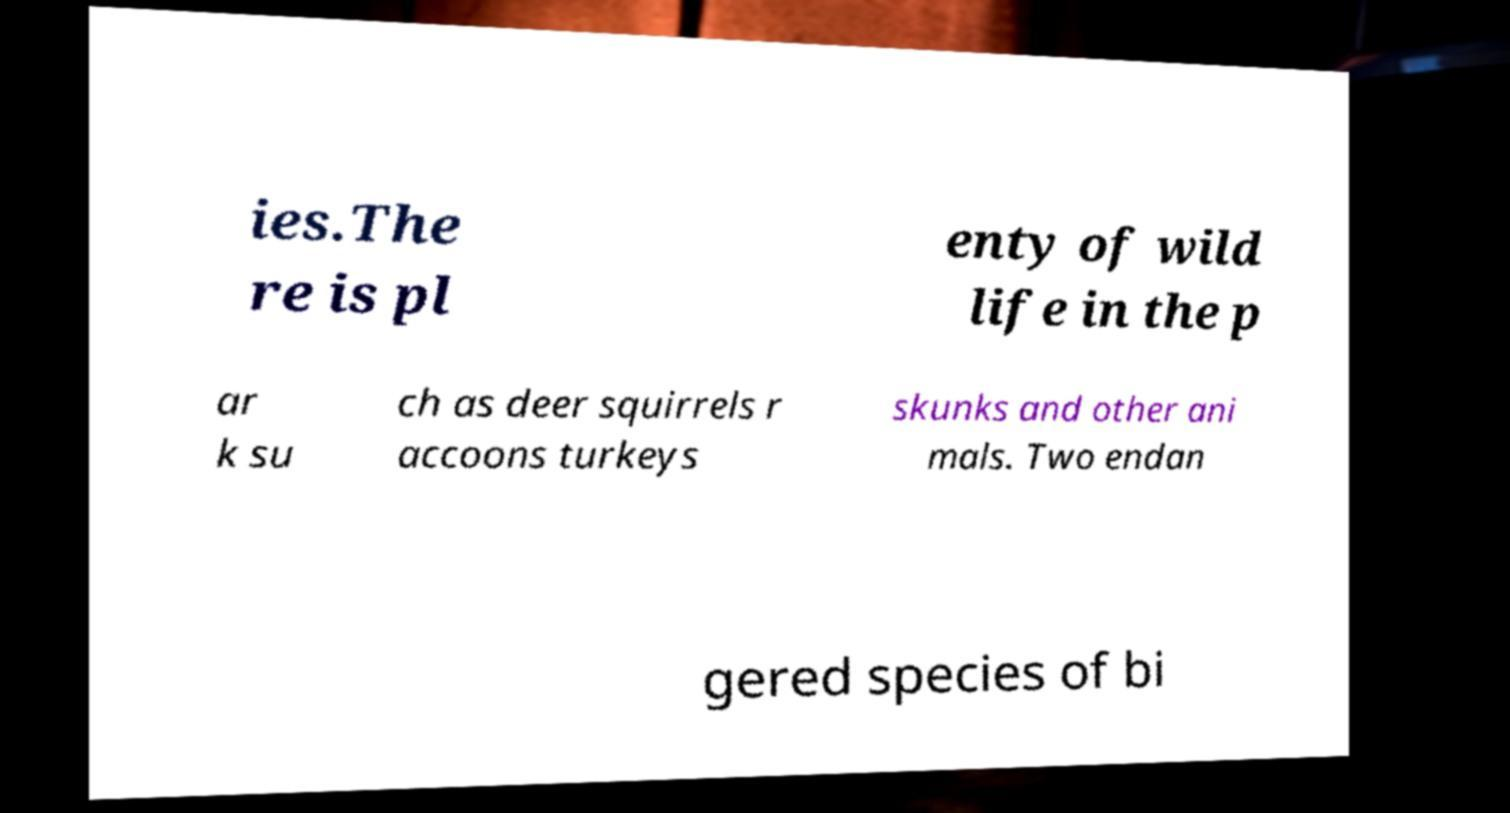Please identify and transcribe the text found in this image. ies.The re is pl enty of wild life in the p ar k su ch as deer squirrels r accoons turkeys skunks and other ani mals. Two endan gered species of bi 